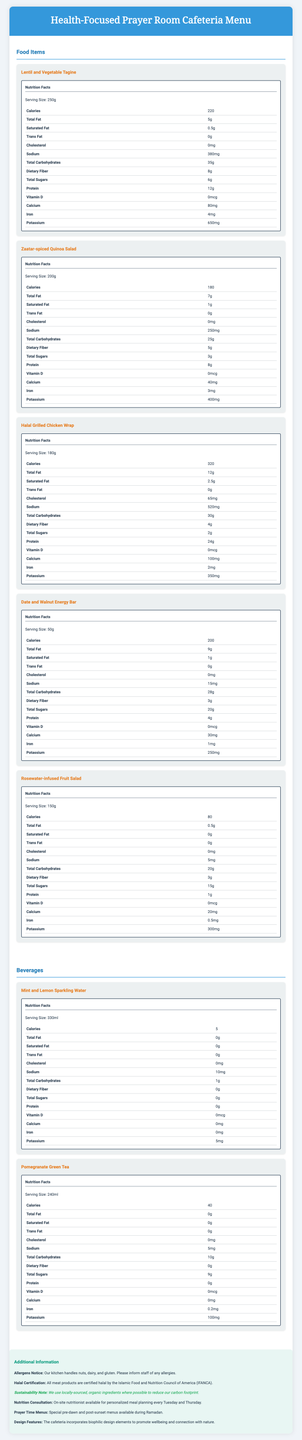what is the serving size of the Lentil and Vegetable Tagine? The serving size for each menu item is explicitly listed under the "Nutrition Facts" section for that item. For the Lentil and Vegetable Tagine, it's 250g.
Answer: 250g How many calories does the Zaatar-spiced Quinoa Salad contain? Under the "Nutrition Facts" section of each menu item, the calorie content is listed. The Zaatar-spiced Quinoa Salad contains 180 calories.
Answer: 180 Which food item has the highest amount of protein? A. Lentil and Vegetable Tagine B. Zaatar-spiced Quinoa Salad C. Halal Grilled Chicken Wrap D. Date and Walnut Energy Bar The Halal Grilled Chicken Wrap has 24g of protein, which is higher than the other listed options.
Answer: C What is the sodium content in the Halal Grilled Chicken Wrap? The sodium content for each item is listed in the "Nutrition Facts" section. For the Halal Grilled Chicken Wrap, it is 520mg.
Answer: 520mg How much total fat is in the Mint and Lemon Sparkling Water? The nutrition label for the Mint and Lemon Sparkling Water shows that it contains 0g of total fat.
Answer: 0g Which beverage has higher potassium content? A. Mint and Lemon Sparkling Water B. Pomegranate Green Tea The Pomegranate Green Tea has 100mg of potassium whereas the Mint and Lemon Sparkling Water has only 5mg.
Answer: B Is the Date and Walnut Energy Bar gluten-free? The document mentions that the kitchen handles gluten but does not specify if the Date and Walnut Energy Bar itself is gluten-free.
Answer: Cannot be determined Are all meat products halal certified? The additional information section clearly states that all meat products are certified halal by the Islamic Food and Nutrition Council of America (IFANCA).
Answer: Yes Describe the overall design and menu focus of the health-focused prayer room cafeteria. The additional information section provides details on design features, sustainability notes, halal certification, and nutrition consultation, emphasizing health and environmental consciousness.
Answer: The design incorporates biophilic elements to promote wellbeing and highlights health-conscious food options, with a focus on locally-sourced, organic, and halal-certified ingredients. How much vitamin D is in the Rosewater-infused Fruit Salad? The nutrition label for the Rosewater-infused Fruit Salad shows that it contains 0mcg of vitamin D.
Answer: 0mcg What type of protein content does the Zaatar-spiced Quinoa Salad contain? The nutrition label for the Zaatar-spiced Quinoa Salad shows that it contains 8g of protein.
Answer: 8g Is there on-site nutrition consultation available? The additional information section mentions that an on-site nutritionist is available for personalized meal planning every Tuesday and Thursday.
Answer: Yes Can the Lentil and Vegetable Tagine be classified as low-sodium? The Lentil and Vegetable Tagine has 380mg of sodium which may not be considered low-sodium for individuals on a restricted diet.
Answer: No 